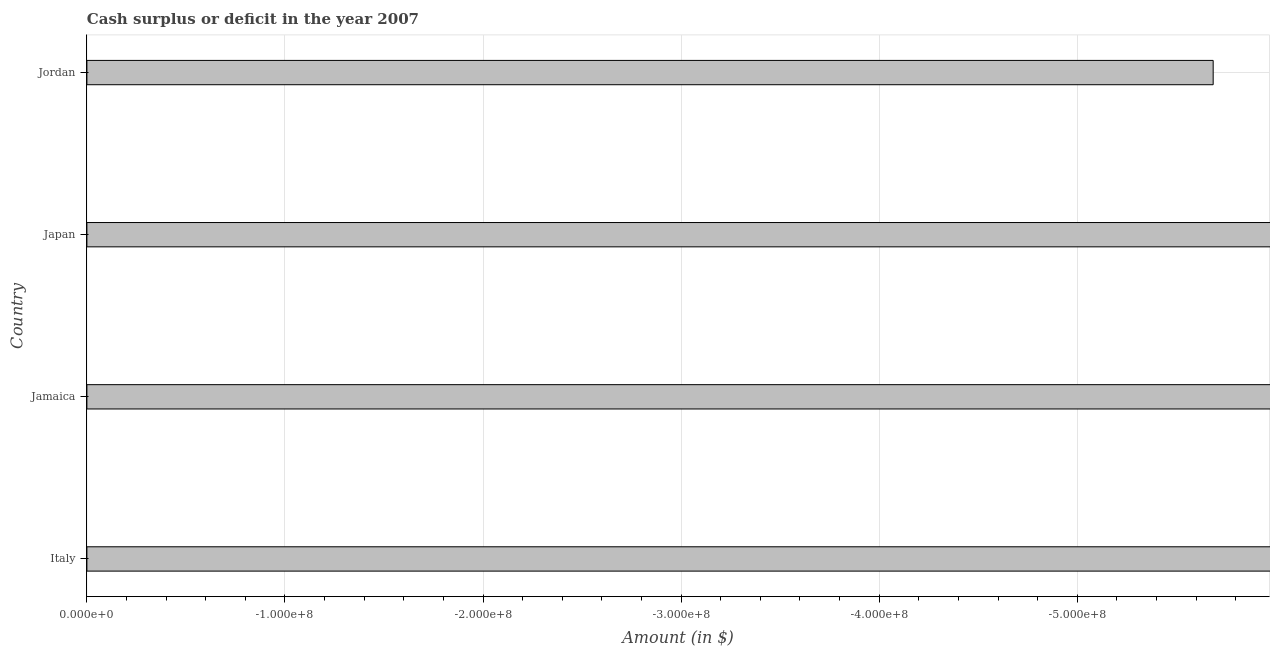What is the title of the graph?
Ensure brevity in your answer.  Cash surplus or deficit in the year 2007. What is the label or title of the X-axis?
Provide a succinct answer. Amount (in $). What is the label or title of the Y-axis?
Give a very brief answer. Country. What is the cash surplus or deficit in Japan?
Give a very brief answer. 0. Across all countries, what is the minimum cash surplus or deficit?
Your response must be concise. 0. What is the sum of the cash surplus or deficit?
Your answer should be very brief. 0. What is the median cash surplus or deficit?
Your response must be concise. 0. In how many countries, is the cash surplus or deficit greater than the average cash surplus or deficit taken over all countries?
Your answer should be very brief. 0. How many countries are there in the graph?
Offer a terse response. 4. Are the values on the major ticks of X-axis written in scientific E-notation?
Provide a succinct answer. Yes. What is the Amount (in $) in Japan?
Make the answer very short. 0. What is the Amount (in $) in Jordan?
Keep it short and to the point. 0. 